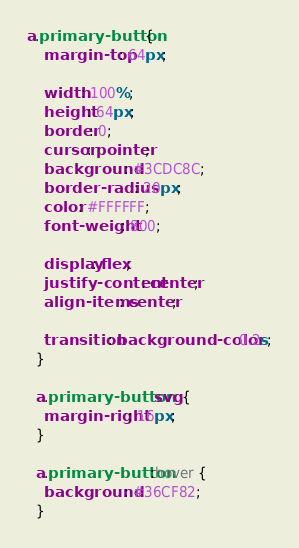<code> <loc_0><loc_0><loc_500><loc_500><_CSS_>a.primary-button {
    margin-top: 64px;
  
    width: 100%;
    height: 64px;
    border: 0;
    cursor: pointer;
    background: #3CDC8C;
    border-radius: 20px;
    color: #FFFFFF;
    font-weight: 800;
  
    display: flex;
    justify-content: center;
    align-items: center;
  
    transition: background-color 0.2s;
  }
  
  a.primary-button svg {
    margin-right: 16px;
  }
  
  a.primary-button:hover {
    background: #36CF82;
  }</code> 